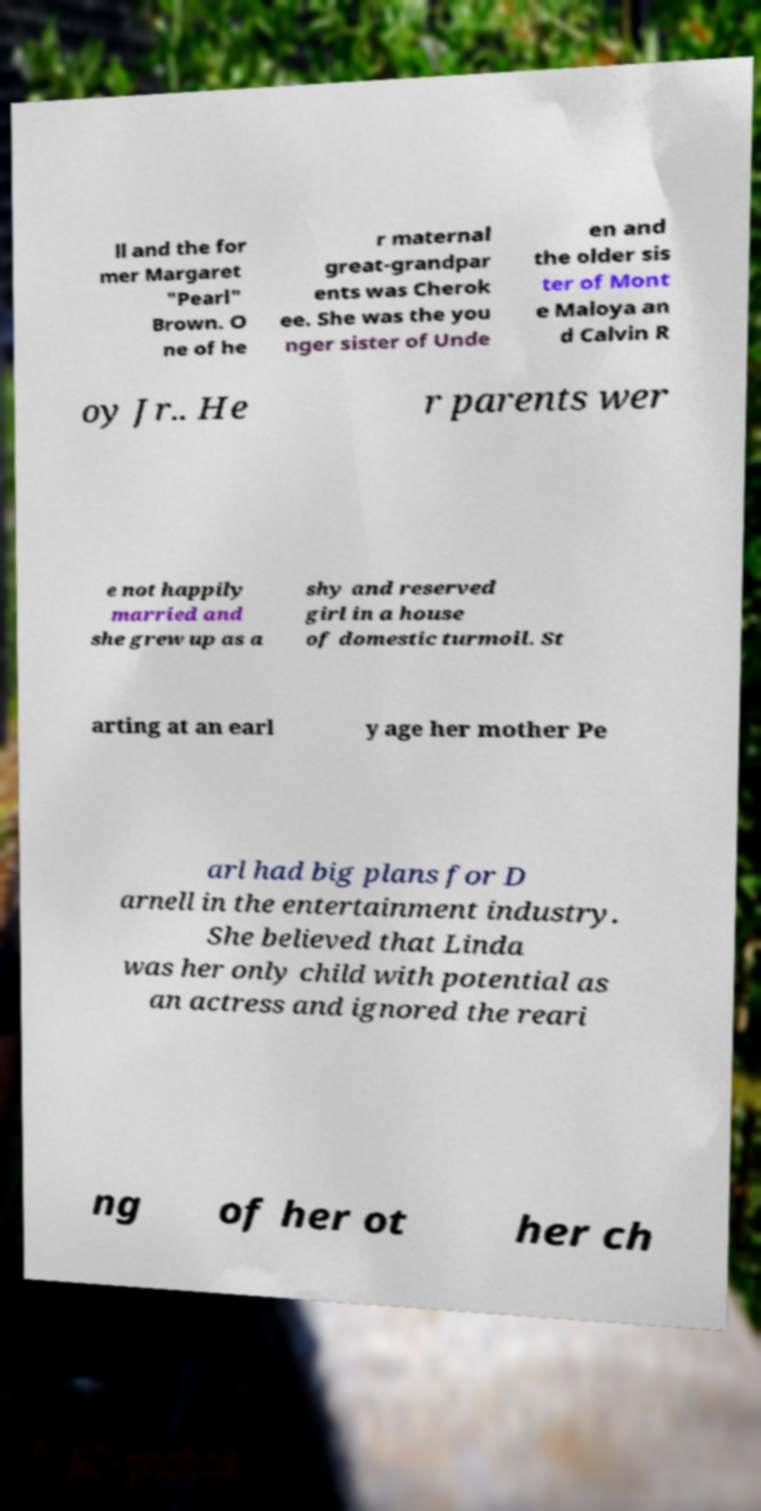Please read and relay the text visible in this image. What does it say? ll and the for mer Margaret "Pearl" Brown. O ne of he r maternal great-grandpar ents was Cherok ee. She was the you nger sister of Unde en and the older sis ter of Mont e Maloya an d Calvin R oy Jr.. He r parents wer e not happily married and she grew up as a shy and reserved girl in a house of domestic turmoil. St arting at an earl y age her mother Pe arl had big plans for D arnell in the entertainment industry. She believed that Linda was her only child with potential as an actress and ignored the reari ng of her ot her ch 